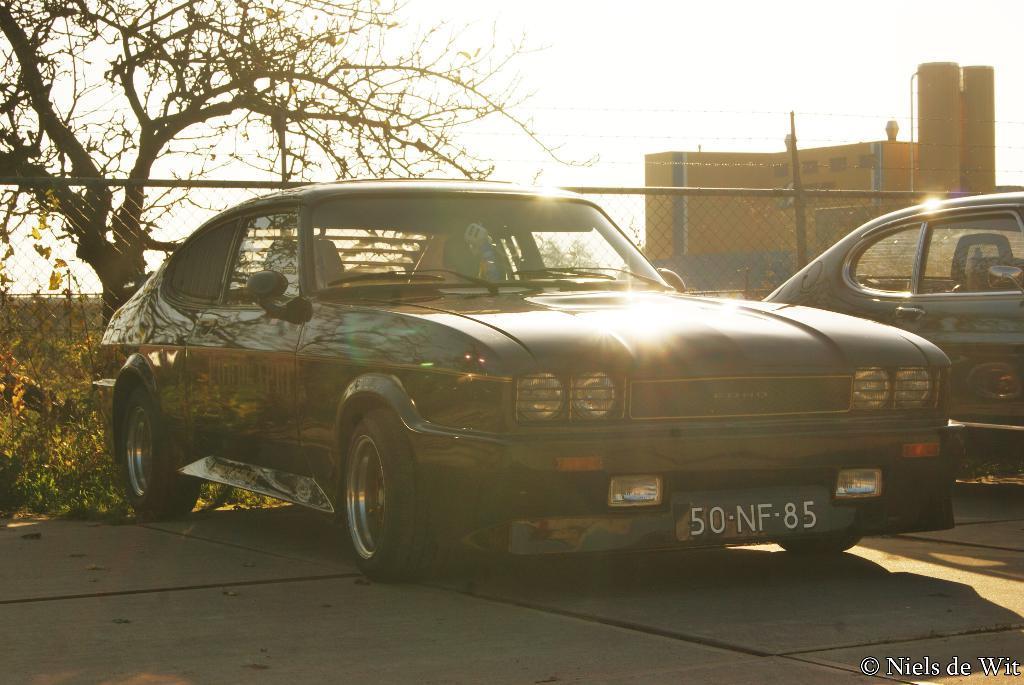In one or two sentences, can you explain what this image depicts? In this picture there are two cars which are parked near to the plants. On the left there is a tree. On the right there was a building. At the top there is a sky. Behind the car i can see the fencing. In the bottom right corner there is a watermark. 